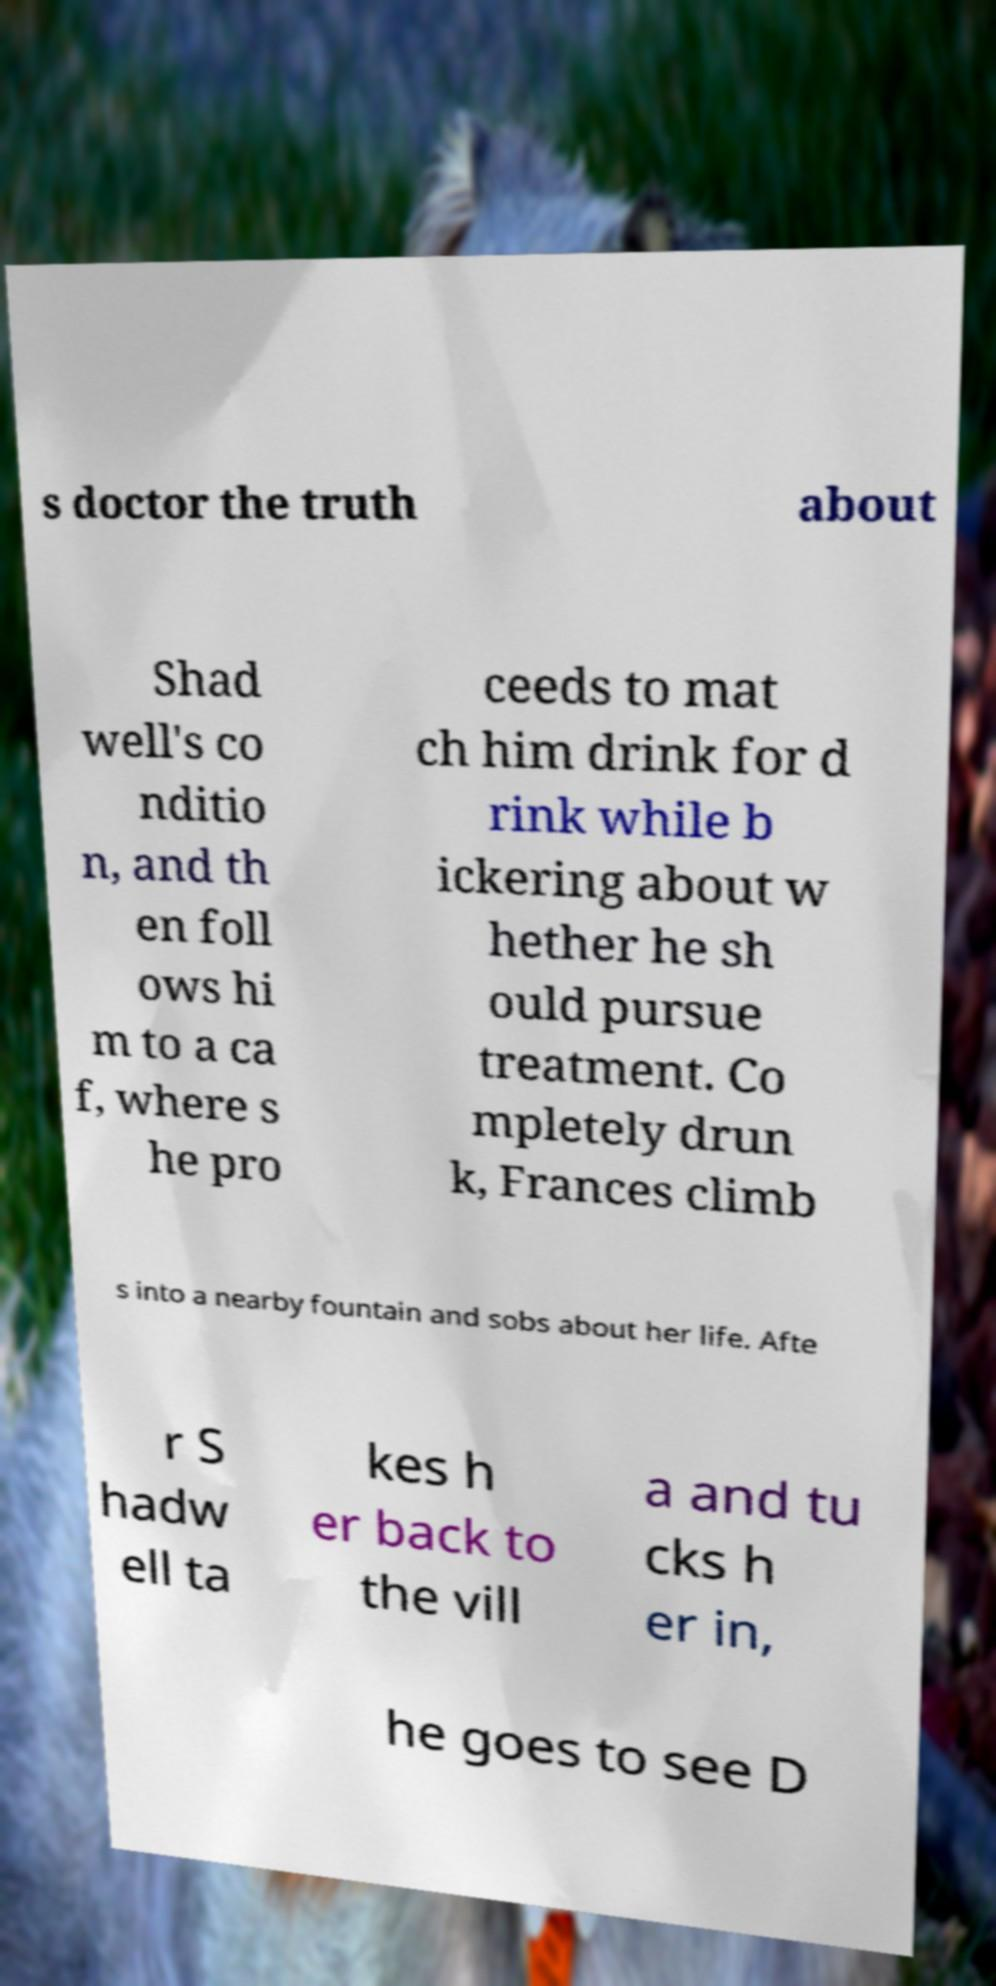Could you extract and type out the text from this image? s doctor the truth about Shad well's co nditio n, and th en foll ows hi m to a ca f, where s he pro ceeds to mat ch him drink for d rink while b ickering about w hether he sh ould pursue treatment. Co mpletely drun k, Frances climb s into a nearby fountain and sobs about her life. Afte r S hadw ell ta kes h er back to the vill a and tu cks h er in, he goes to see D 